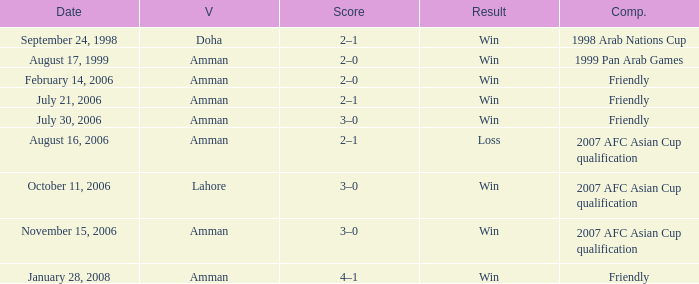Can you give me this table as a dict? {'header': ['Date', 'V', 'Score', 'Result', 'Comp.'], 'rows': [['September 24, 1998', 'Doha', '2–1', 'Win', '1998 Arab Nations Cup'], ['August 17, 1999', 'Amman', '2–0', 'Win', '1999 Pan Arab Games'], ['February 14, 2006', 'Amman', '2–0', 'Win', 'Friendly'], ['July 21, 2006', 'Amman', '2–1', 'Win', 'Friendly'], ['July 30, 2006', 'Amman', '3–0', 'Win', 'Friendly'], ['August 16, 2006', 'Amman', '2–1', 'Loss', '2007 AFC Asian Cup qualification'], ['October 11, 2006', 'Lahore', '3–0', 'Win', '2007 AFC Asian Cup qualification'], ['November 15, 2006', 'Amman', '3–0', 'Win', '2007 AFC Asian Cup qualification'], ['January 28, 2008', 'Amman', '4–1', 'Win', 'Friendly']]} Where did Ra'fat Ali play on August 17, 1999? Amman. 